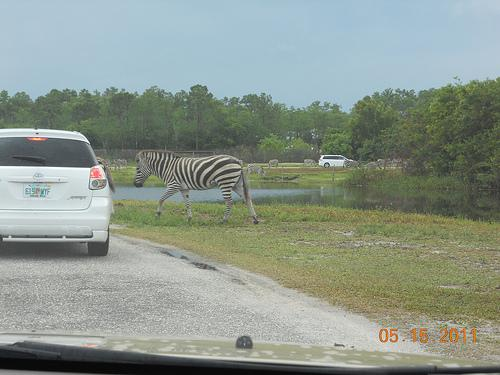Question: what is the animal?
Choices:
A. The horse.
B. The donkey.
C. The zebra.
D. The mule.
Answer with the letter. Answer: C Question: where is the white car?
Choices:
A. In the driveway.
B. On the road.
C. In the parking lot.
D. On the sidewalk.
Answer with the letter. Answer: B Question: what color is the zebra?
Choices:
A. Black and white.
B. Brown and black.
C. White and Grey.
D. Reddish black.
Answer with the letter. Answer: A 